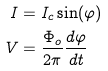<formula> <loc_0><loc_0><loc_500><loc_500>I & = I _ { c } \sin ( \varphi ) \\ V & = \frac { \Phi _ { o } } { 2 \pi } \frac { d \varphi } { d t }</formula> 